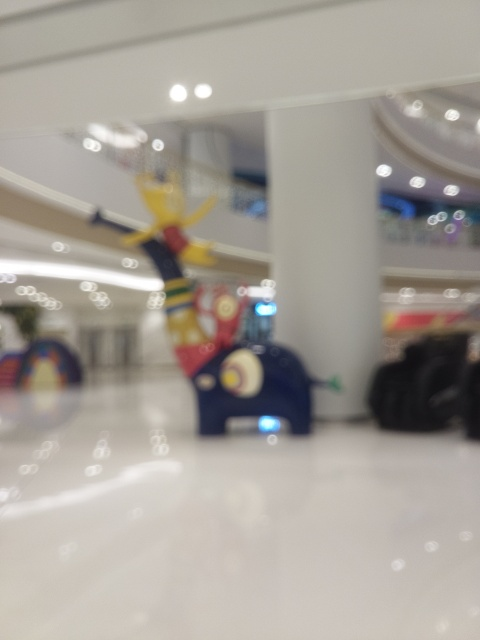Can you describe the environment where this photo was taken? The photo appears to be taken inside a spacious indoor area with a high ceiling, perhaps a shopping mall or an exhibition center. The bright and blurred lights suggest that it's well-lit, likely with artificial lighting typical of such indoor settings. 